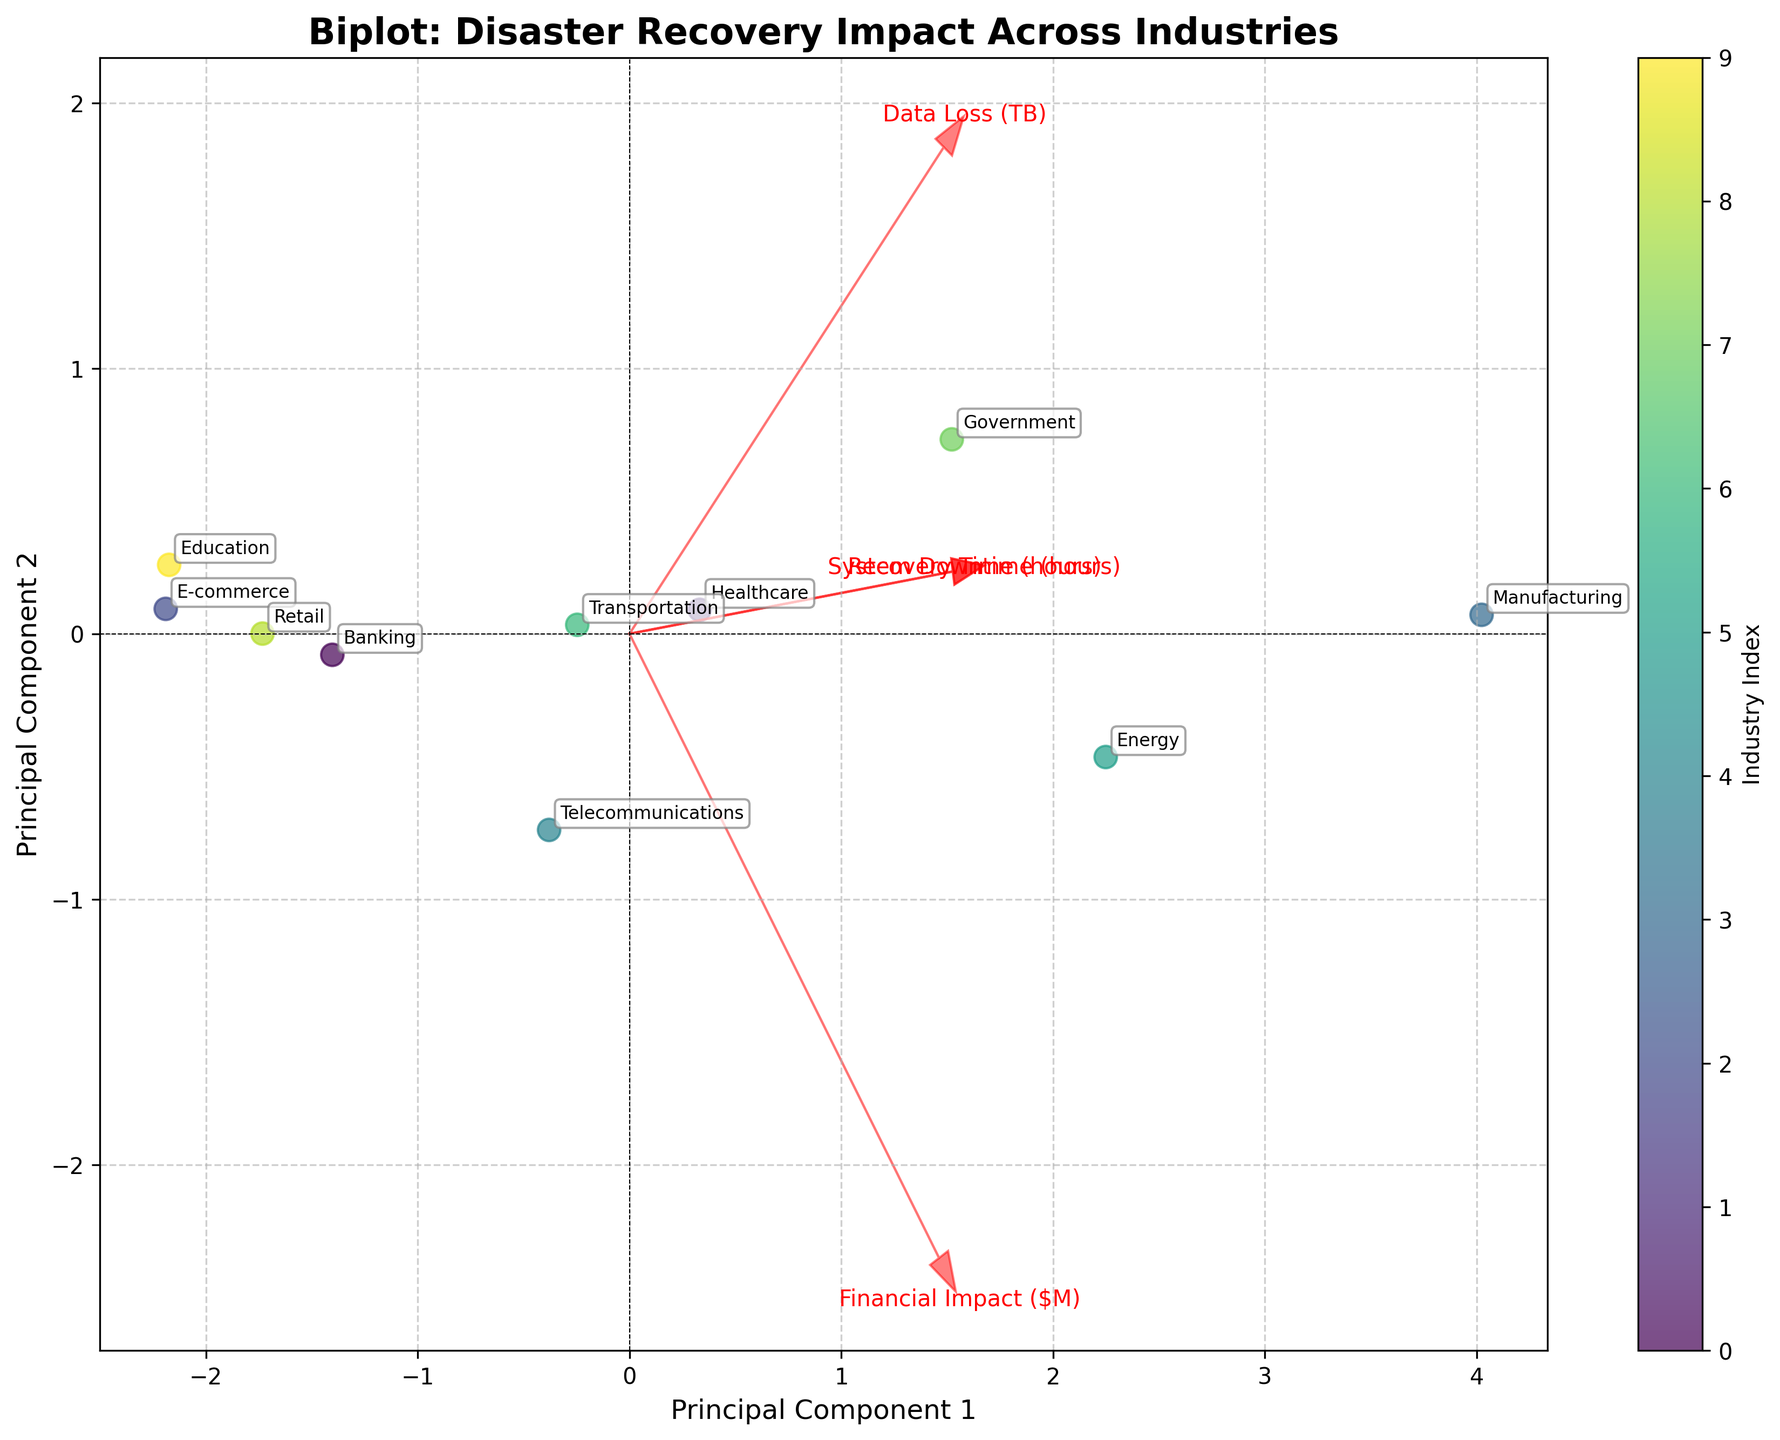What is the title of the figure? Look at the top of the figure where the title is usually placed.
Answer: Biplot: Disaster Recovery Impact Across Industries How many data points are plotted on the graph? Each data point represents an industry. Count the number of distinct scatter points or look at the color map's labels.
Answer: 10 Which industry appears at the highest principal component 2 (PC2) value? Identify the scatter point that is highest on the y-axis and read the label next to it.
Answer: Telecommunications Which industry appears at the lowest principal component 1 (PC1) value? Identify the scatter point that is farthest to the left on the x-axis and read the label next to it.
Answer: Retail Between which two industries is the smallest distance observed in the PC1/PC2 plane? Look for the two scatter points that are closest to each other on the biplot and read the labels next to them.
Answer: Education and Retail Which feature vector has the largest projection onto PC1? Identify which of the arrow vectors extends farthest along the x-axis (PC1).
Answer: Financial Impact ($M) What can be inferred about the correlation between System Downtime (hours) and Financial Impact ($M)? Observe the directions of the arrows representing these features. If they point in similar directions, there is a positive correlation; if opposite, a negative correlation.
Answer: They are positively correlated How does the Recovery Time (hours) feature vector align with PC2? Look at the direction of the Recovery Time (hours) vector in relation to the y-axis (PC2).
Answer: It is positively aligned Which industry has the highest overall impact regarding all features combined? The points farther from the origin in both PC1 and PC2 directions likely represent higher overall impact.
Answer: Manufacturing Do Data Loss (TB) and System Downtime (hours) show similar or opposite trends? Compare the directions of their arrows. If they point in similar directions, they show similar trends; if opposite, they show opposite trends.
Answer: Similar trends 